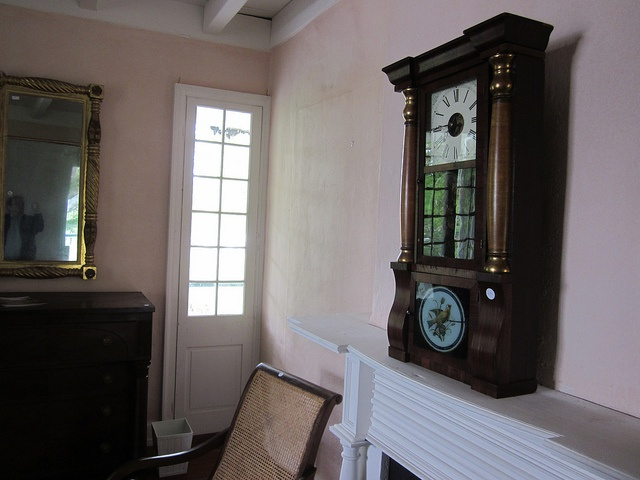Describe the objects in this image and their specific colors. I can see chair in gray, black, and maroon tones and clock in gray, darkgray, and black tones in this image. 